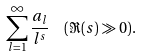Convert formula to latex. <formula><loc_0><loc_0><loc_500><loc_500>\sum _ { l = 1 } ^ { \infty } \frac { a _ { l } } { l ^ { s } } \ \ ( \Re ( s ) \gg 0 ) .</formula> 